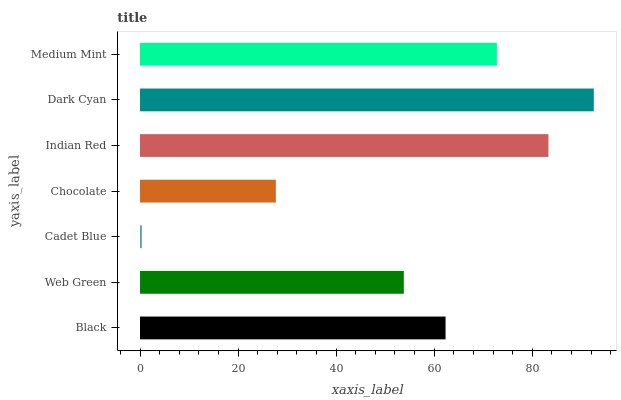Is Cadet Blue the minimum?
Answer yes or no. Yes. Is Dark Cyan the maximum?
Answer yes or no. Yes. Is Web Green the minimum?
Answer yes or no. No. Is Web Green the maximum?
Answer yes or no. No. Is Black greater than Web Green?
Answer yes or no. Yes. Is Web Green less than Black?
Answer yes or no. Yes. Is Web Green greater than Black?
Answer yes or no. No. Is Black less than Web Green?
Answer yes or no. No. Is Black the high median?
Answer yes or no. Yes. Is Black the low median?
Answer yes or no. Yes. Is Medium Mint the high median?
Answer yes or no. No. Is Medium Mint the low median?
Answer yes or no. No. 